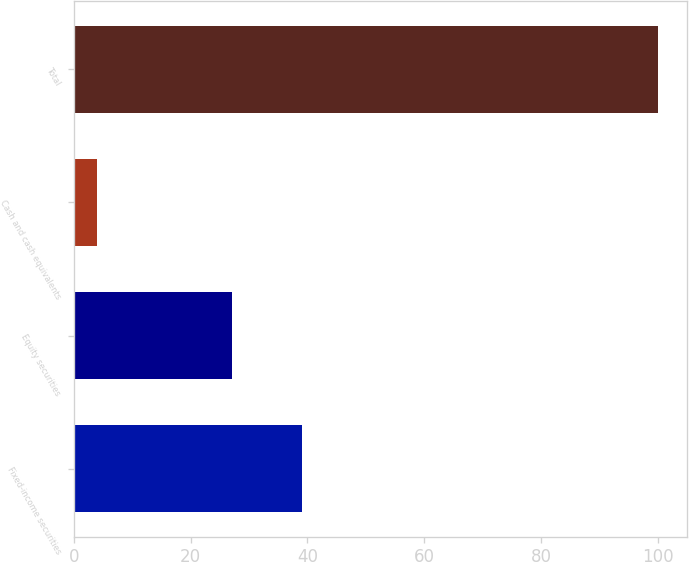Convert chart to OTSL. <chart><loc_0><loc_0><loc_500><loc_500><bar_chart><fcel>Fixed-income securities<fcel>Equity securities<fcel>Cash and cash equivalents<fcel>Total<nl><fcel>39<fcel>27<fcel>4<fcel>100<nl></chart> 